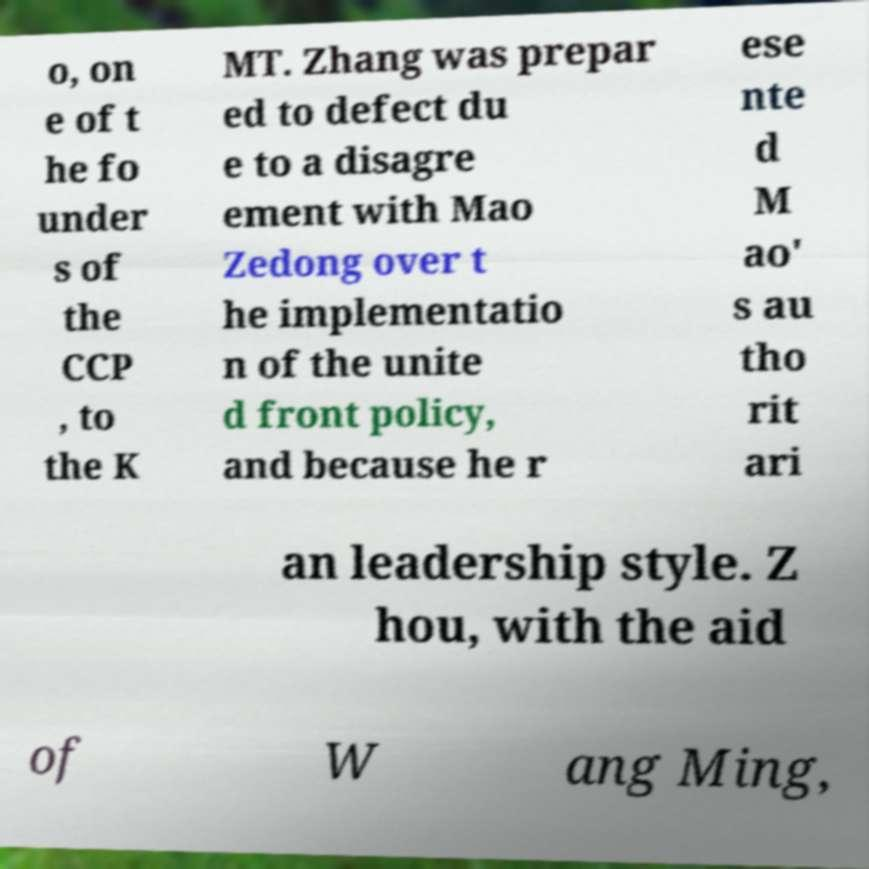There's text embedded in this image that I need extracted. Can you transcribe it verbatim? o, on e of t he fo under s of the CCP , to the K MT. Zhang was prepar ed to defect du e to a disagre ement with Mao Zedong over t he implementatio n of the unite d front policy, and because he r ese nte d M ao' s au tho rit ari an leadership style. Z hou, with the aid of W ang Ming, 